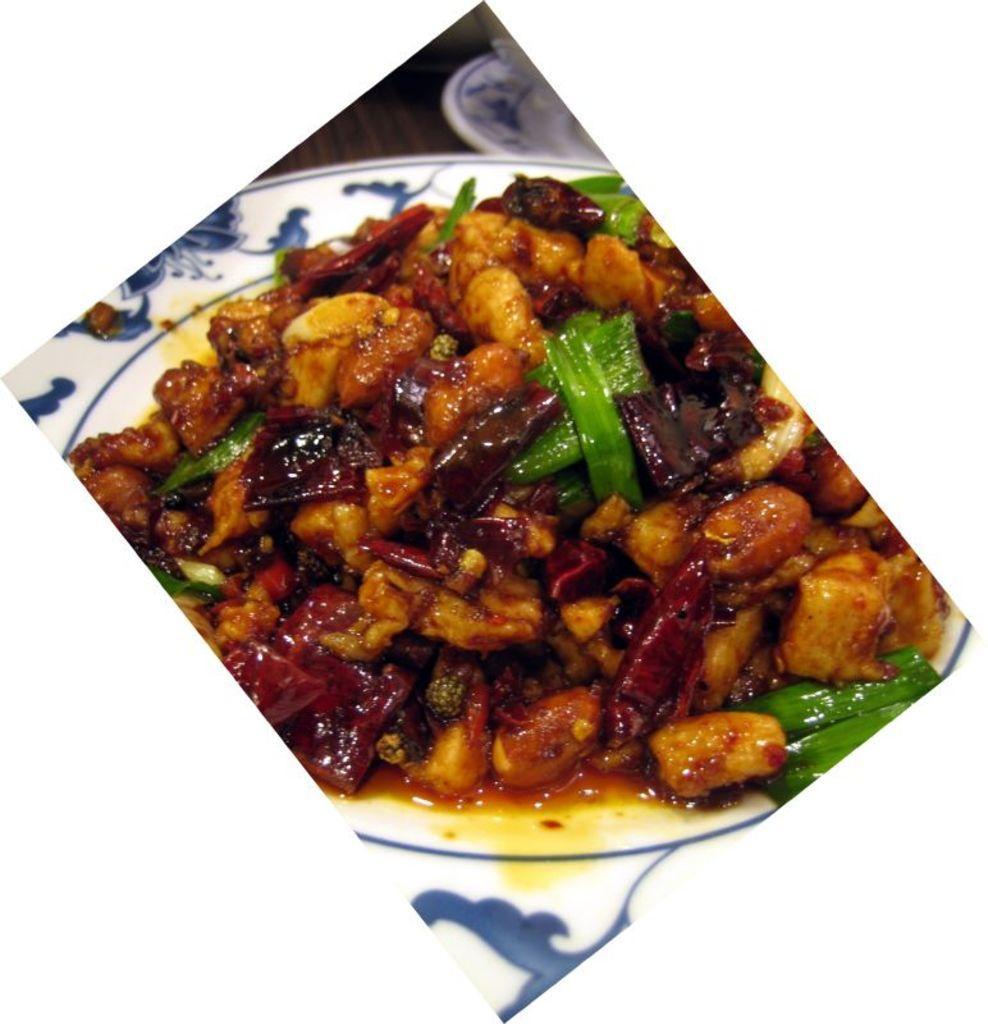In one or two sentences, can you explain what this image depicts? In this picture we can see a plate, there is some food present in this plate. 